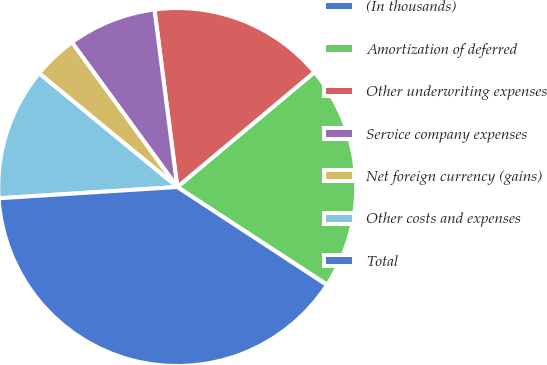<chart> <loc_0><loc_0><loc_500><loc_500><pie_chart><fcel>(In thousands)<fcel>Amortization of deferred<fcel>Other underwriting expenses<fcel>Service company expenses<fcel>Net foreign currency (gains)<fcel>Other costs and expenses<fcel>Total<nl><fcel>0.04%<fcel>20.28%<fcel>15.94%<fcel>7.99%<fcel>4.02%<fcel>11.96%<fcel>39.77%<nl></chart> 